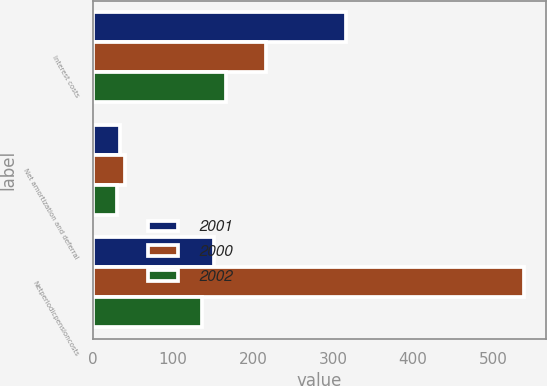Convert chart. <chart><loc_0><loc_0><loc_500><loc_500><stacked_bar_chart><ecel><fcel>Interest costs<fcel>Net amortization and deferral<fcel>Netperiodicpensioncosts<nl><fcel>2001<fcel>317<fcel>34<fcel>152<nl><fcel>2000<fcel>216<fcel>40<fcel>539<nl><fcel>2002<fcel>167<fcel>30<fcel>137<nl></chart> 